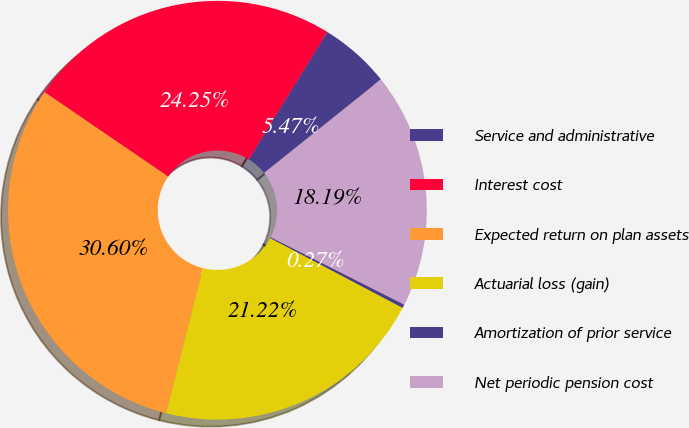Convert chart to OTSL. <chart><loc_0><loc_0><loc_500><loc_500><pie_chart><fcel>Service and administrative<fcel>Interest cost<fcel>Expected return on plan assets<fcel>Actuarial loss (gain)<fcel>Amortization of prior service<fcel>Net periodic pension cost<nl><fcel>5.47%<fcel>24.25%<fcel>30.6%<fcel>21.22%<fcel>0.27%<fcel>18.19%<nl></chart> 